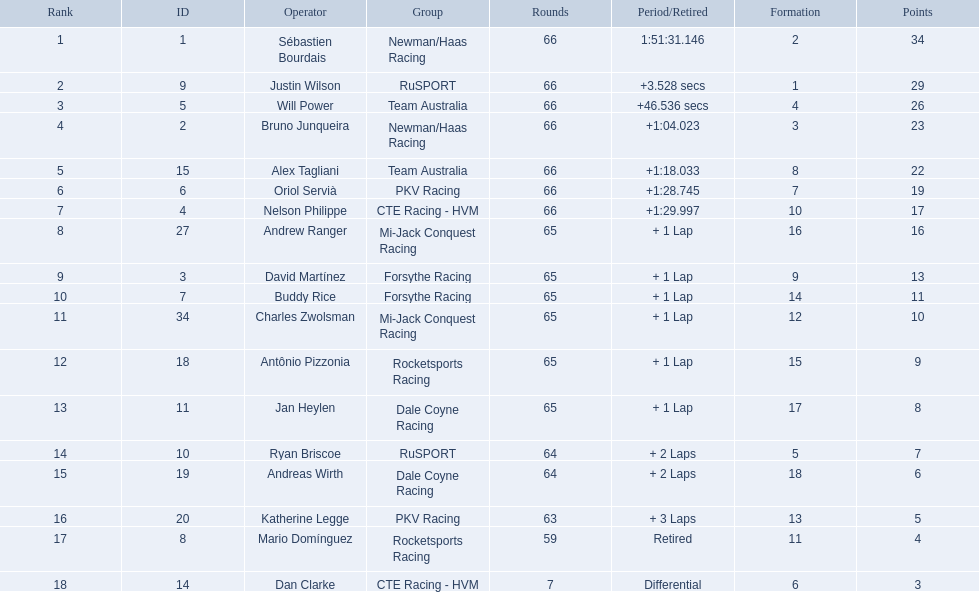Who are all the drivers? Sébastien Bourdais, Justin Wilson, Will Power, Bruno Junqueira, Alex Tagliani, Oriol Servià, Nelson Philippe, Andrew Ranger, David Martínez, Buddy Rice, Charles Zwolsman, Antônio Pizzonia, Jan Heylen, Ryan Briscoe, Andreas Wirth, Katherine Legge, Mario Domínguez, Dan Clarke. What position did they reach? 1, 2, 3, 4, 5, 6, 7, 8, 9, 10, 11, 12, 13, 14, 15, 16, 17, 18. What is the number for each driver? 1, 9, 5, 2, 15, 6, 4, 27, 3, 7, 34, 18, 11, 10, 19, 20, 8, 14. And which player's number and position match? Sébastien Bourdais. 